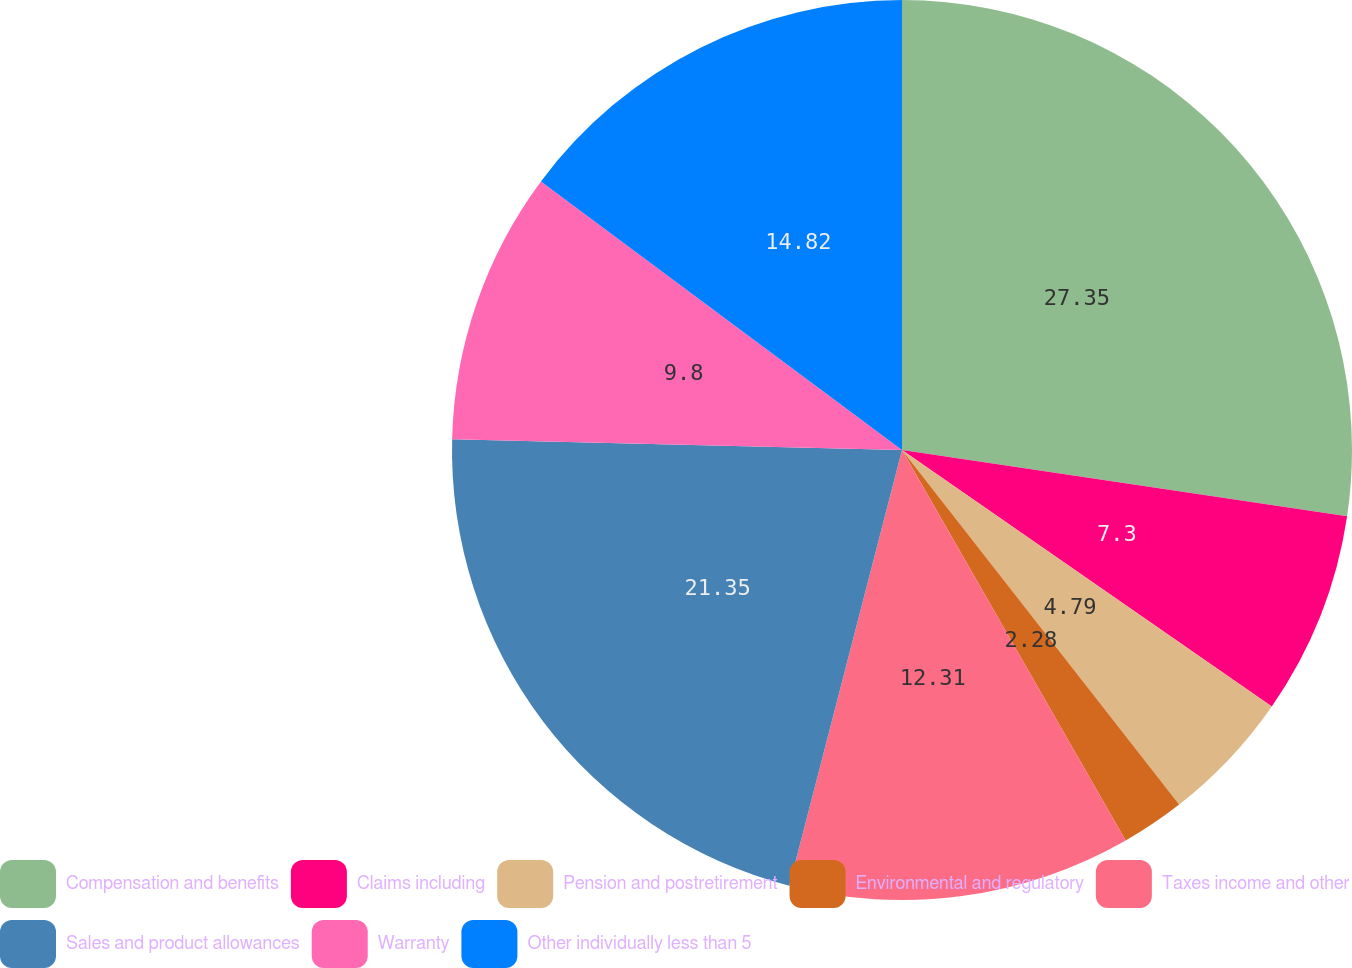<chart> <loc_0><loc_0><loc_500><loc_500><pie_chart><fcel>Compensation and benefits<fcel>Claims including<fcel>Pension and postretirement<fcel>Environmental and regulatory<fcel>Taxes income and other<fcel>Sales and product allowances<fcel>Warranty<fcel>Other individually less than 5<nl><fcel>27.35%<fcel>7.3%<fcel>4.79%<fcel>2.28%<fcel>12.31%<fcel>21.35%<fcel>9.8%<fcel>14.82%<nl></chart> 